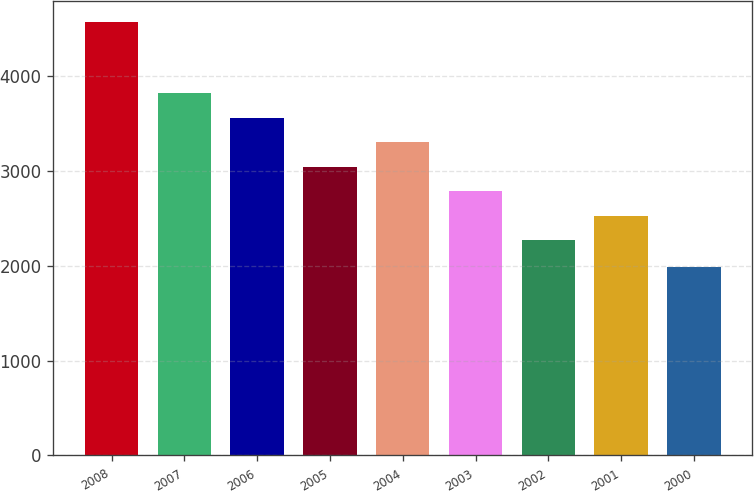Convert chart. <chart><loc_0><loc_0><loc_500><loc_500><bar_chart><fcel>2008<fcel>2007<fcel>2006<fcel>2005<fcel>2004<fcel>2003<fcel>2002<fcel>2001<fcel>2000<nl><fcel>4564<fcel>3814.8<fcel>3556.5<fcel>3039.9<fcel>3298.2<fcel>2781.6<fcel>2265<fcel>2523.3<fcel>1981<nl></chart> 